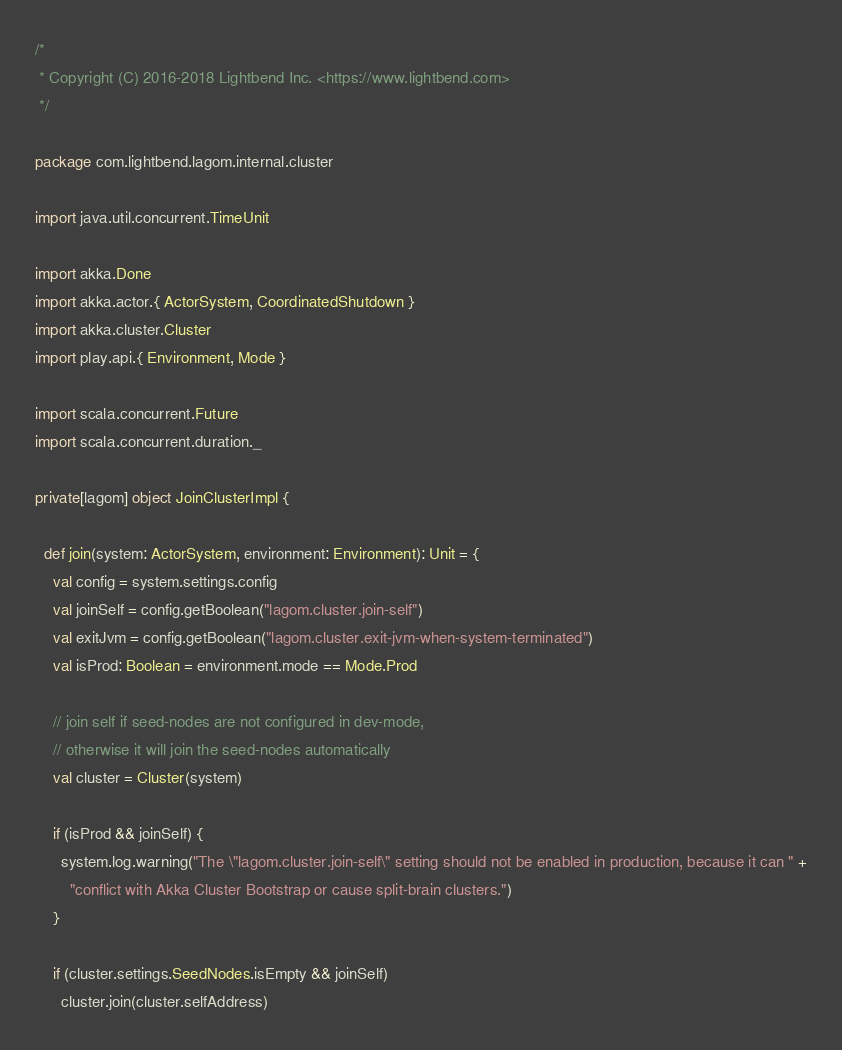<code> <loc_0><loc_0><loc_500><loc_500><_Scala_>/*
 * Copyright (C) 2016-2018 Lightbend Inc. <https://www.lightbend.com>
 */

package com.lightbend.lagom.internal.cluster

import java.util.concurrent.TimeUnit

import akka.Done
import akka.actor.{ ActorSystem, CoordinatedShutdown }
import akka.cluster.Cluster
import play.api.{ Environment, Mode }

import scala.concurrent.Future
import scala.concurrent.duration._

private[lagom] object JoinClusterImpl {

  def join(system: ActorSystem, environment: Environment): Unit = {
    val config = system.settings.config
    val joinSelf = config.getBoolean("lagom.cluster.join-self")
    val exitJvm = config.getBoolean("lagom.cluster.exit-jvm-when-system-terminated")
    val isProd: Boolean = environment.mode == Mode.Prod

    // join self if seed-nodes are not configured in dev-mode,
    // otherwise it will join the seed-nodes automatically
    val cluster = Cluster(system)

    if (isProd && joinSelf) {
      system.log.warning("The \"lagom.cluster.join-self\" setting should not be enabled in production, because it can " +
        "conflict with Akka Cluster Bootstrap or cause split-brain clusters.")
    }

    if (cluster.settings.SeedNodes.isEmpty && joinSelf)
      cluster.join(cluster.selfAddress)
</code> 